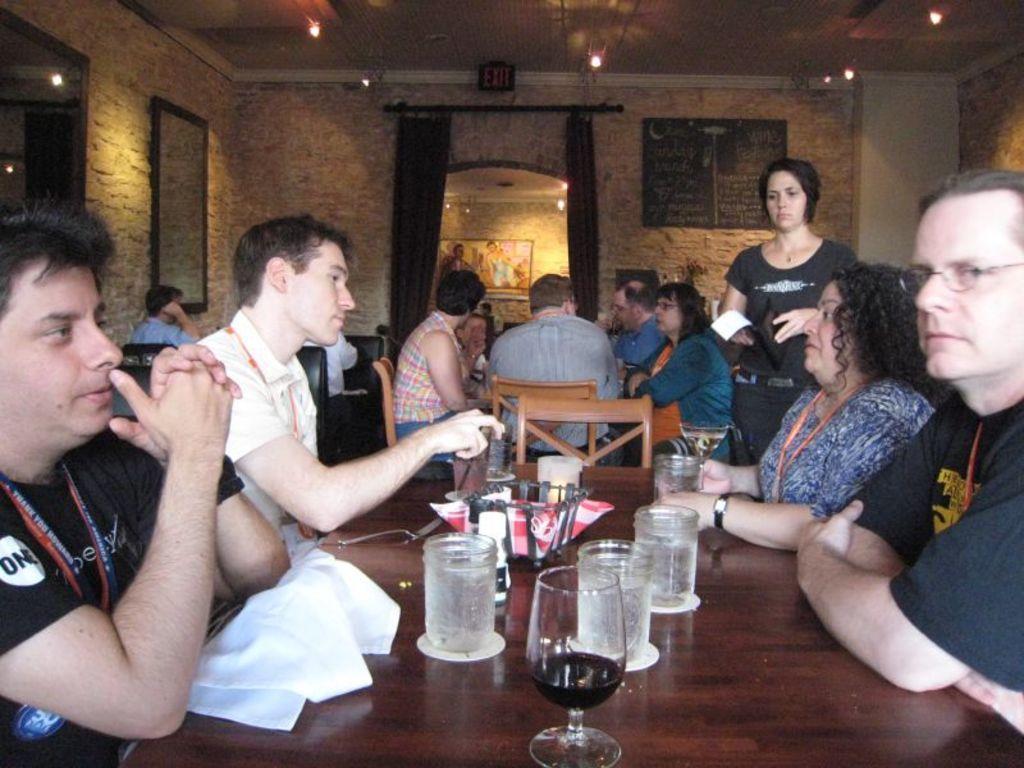Please provide a concise description of this image. In this image I can see people where one woman is standing and rest all are sitting on chairs. I can also see a table and on this table I can see few glasses. In the background I can see a board and few curtains. 